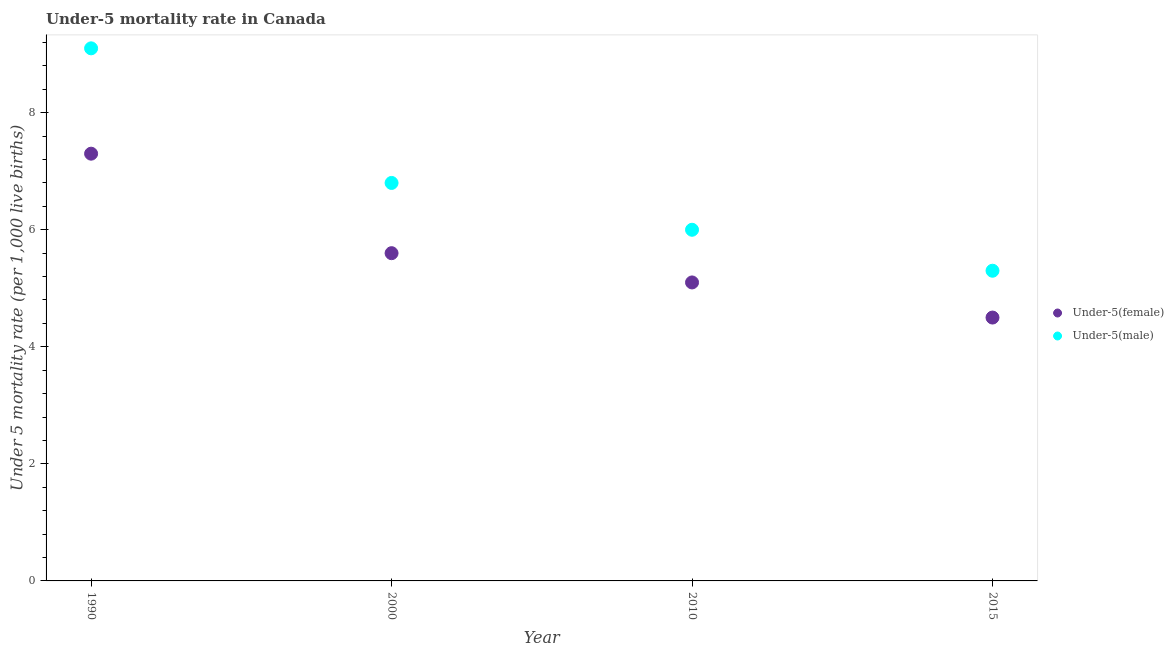Across all years, what is the minimum under-5 male mortality rate?
Keep it short and to the point. 5.3. In which year was the under-5 male mortality rate maximum?
Ensure brevity in your answer.  1990. In which year was the under-5 female mortality rate minimum?
Ensure brevity in your answer.  2015. What is the total under-5 male mortality rate in the graph?
Keep it short and to the point. 27.2. What is the difference between the under-5 female mortality rate in 2010 and that in 2015?
Ensure brevity in your answer.  0.6. What is the average under-5 female mortality rate per year?
Your response must be concise. 5.62. In the year 2010, what is the difference between the under-5 male mortality rate and under-5 female mortality rate?
Your response must be concise. 0.9. In how many years, is the under-5 male mortality rate greater than 5.6?
Make the answer very short. 3. What is the ratio of the under-5 male mortality rate in 1990 to that in 2015?
Offer a terse response. 1.72. Is the difference between the under-5 male mortality rate in 1990 and 2015 greater than the difference between the under-5 female mortality rate in 1990 and 2015?
Offer a very short reply. Yes. What is the difference between the highest and the second highest under-5 female mortality rate?
Provide a short and direct response. 1.7. What is the difference between the highest and the lowest under-5 female mortality rate?
Offer a very short reply. 2.8. In how many years, is the under-5 female mortality rate greater than the average under-5 female mortality rate taken over all years?
Offer a very short reply. 1. Is the sum of the under-5 male mortality rate in 2000 and 2015 greater than the maximum under-5 female mortality rate across all years?
Provide a succinct answer. Yes. Does the under-5 male mortality rate monotonically increase over the years?
Keep it short and to the point. No. Is the under-5 male mortality rate strictly greater than the under-5 female mortality rate over the years?
Make the answer very short. Yes. How many years are there in the graph?
Your answer should be compact. 4. What is the difference between two consecutive major ticks on the Y-axis?
Your answer should be very brief. 2. Does the graph contain any zero values?
Keep it short and to the point. No. Does the graph contain grids?
Provide a short and direct response. No. How are the legend labels stacked?
Provide a succinct answer. Vertical. What is the title of the graph?
Your answer should be very brief. Under-5 mortality rate in Canada. What is the label or title of the X-axis?
Offer a terse response. Year. What is the label or title of the Y-axis?
Ensure brevity in your answer.  Under 5 mortality rate (per 1,0 live births). What is the Under 5 mortality rate (per 1,000 live births) of Under-5(female) in 1990?
Provide a short and direct response. 7.3. What is the Under 5 mortality rate (per 1,000 live births) in Under-5(female) in 2000?
Your answer should be compact. 5.6. What is the Under 5 mortality rate (per 1,000 live births) in Under-5(male) in 2000?
Your answer should be compact. 6.8. What is the Under 5 mortality rate (per 1,000 live births) of Under-5(female) in 2010?
Your answer should be very brief. 5.1. What is the Under 5 mortality rate (per 1,000 live births) of Under-5(male) in 2010?
Offer a terse response. 6. What is the Under 5 mortality rate (per 1,000 live births) of Under-5(male) in 2015?
Provide a succinct answer. 5.3. What is the total Under 5 mortality rate (per 1,000 live births) in Under-5(female) in the graph?
Make the answer very short. 22.5. What is the total Under 5 mortality rate (per 1,000 live births) of Under-5(male) in the graph?
Keep it short and to the point. 27.2. What is the difference between the Under 5 mortality rate (per 1,000 live births) of Under-5(female) in 1990 and that in 2000?
Your response must be concise. 1.7. What is the difference between the Under 5 mortality rate (per 1,000 live births) of Under-5(male) in 1990 and that in 2000?
Your answer should be very brief. 2.3. What is the difference between the Under 5 mortality rate (per 1,000 live births) of Under-5(male) in 1990 and that in 2010?
Your answer should be compact. 3.1. What is the difference between the Under 5 mortality rate (per 1,000 live births) of Under-5(female) in 1990 and that in 2015?
Keep it short and to the point. 2.8. What is the difference between the Under 5 mortality rate (per 1,000 live births) in Under-5(male) in 1990 and that in 2015?
Your answer should be compact. 3.8. What is the difference between the Under 5 mortality rate (per 1,000 live births) of Under-5(female) in 2000 and that in 2010?
Keep it short and to the point. 0.5. What is the difference between the Under 5 mortality rate (per 1,000 live births) of Under-5(female) in 2000 and that in 2015?
Provide a short and direct response. 1.1. What is the difference between the Under 5 mortality rate (per 1,000 live births) in Under-5(female) in 2010 and that in 2015?
Offer a very short reply. 0.6. What is the difference between the Under 5 mortality rate (per 1,000 live births) in Under-5(female) in 1990 and the Under 5 mortality rate (per 1,000 live births) in Under-5(male) in 2000?
Ensure brevity in your answer.  0.5. What is the difference between the Under 5 mortality rate (per 1,000 live births) in Under-5(female) in 2000 and the Under 5 mortality rate (per 1,000 live births) in Under-5(male) in 2015?
Make the answer very short. 0.3. What is the average Under 5 mortality rate (per 1,000 live births) in Under-5(female) per year?
Offer a very short reply. 5.62. What is the average Under 5 mortality rate (per 1,000 live births) in Under-5(male) per year?
Make the answer very short. 6.8. In the year 2000, what is the difference between the Under 5 mortality rate (per 1,000 live births) of Under-5(female) and Under 5 mortality rate (per 1,000 live births) of Under-5(male)?
Ensure brevity in your answer.  -1.2. In the year 2015, what is the difference between the Under 5 mortality rate (per 1,000 live births) in Under-5(female) and Under 5 mortality rate (per 1,000 live births) in Under-5(male)?
Your answer should be compact. -0.8. What is the ratio of the Under 5 mortality rate (per 1,000 live births) in Under-5(female) in 1990 to that in 2000?
Ensure brevity in your answer.  1.3. What is the ratio of the Under 5 mortality rate (per 1,000 live births) of Under-5(male) in 1990 to that in 2000?
Make the answer very short. 1.34. What is the ratio of the Under 5 mortality rate (per 1,000 live births) in Under-5(female) in 1990 to that in 2010?
Make the answer very short. 1.43. What is the ratio of the Under 5 mortality rate (per 1,000 live births) in Under-5(male) in 1990 to that in 2010?
Offer a very short reply. 1.52. What is the ratio of the Under 5 mortality rate (per 1,000 live births) of Under-5(female) in 1990 to that in 2015?
Your answer should be compact. 1.62. What is the ratio of the Under 5 mortality rate (per 1,000 live births) in Under-5(male) in 1990 to that in 2015?
Offer a very short reply. 1.72. What is the ratio of the Under 5 mortality rate (per 1,000 live births) in Under-5(female) in 2000 to that in 2010?
Provide a succinct answer. 1.1. What is the ratio of the Under 5 mortality rate (per 1,000 live births) of Under-5(male) in 2000 to that in 2010?
Make the answer very short. 1.13. What is the ratio of the Under 5 mortality rate (per 1,000 live births) of Under-5(female) in 2000 to that in 2015?
Keep it short and to the point. 1.24. What is the ratio of the Under 5 mortality rate (per 1,000 live births) of Under-5(male) in 2000 to that in 2015?
Your response must be concise. 1.28. What is the ratio of the Under 5 mortality rate (per 1,000 live births) of Under-5(female) in 2010 to that in 2015?
Ensure brevity in your answer.  1.13. What is the ratio of the Under 5 mortality rate (per 1,000 live births) in Under-5(male) in 2010 to that in 2015?
Ensure brevity in your answer.  1.13. What is the difference between the highest and the lowest Under 5 mortality rate (per 1,000 live births) in Under-5(female)?
Provide a succinct answer. 2.8. 